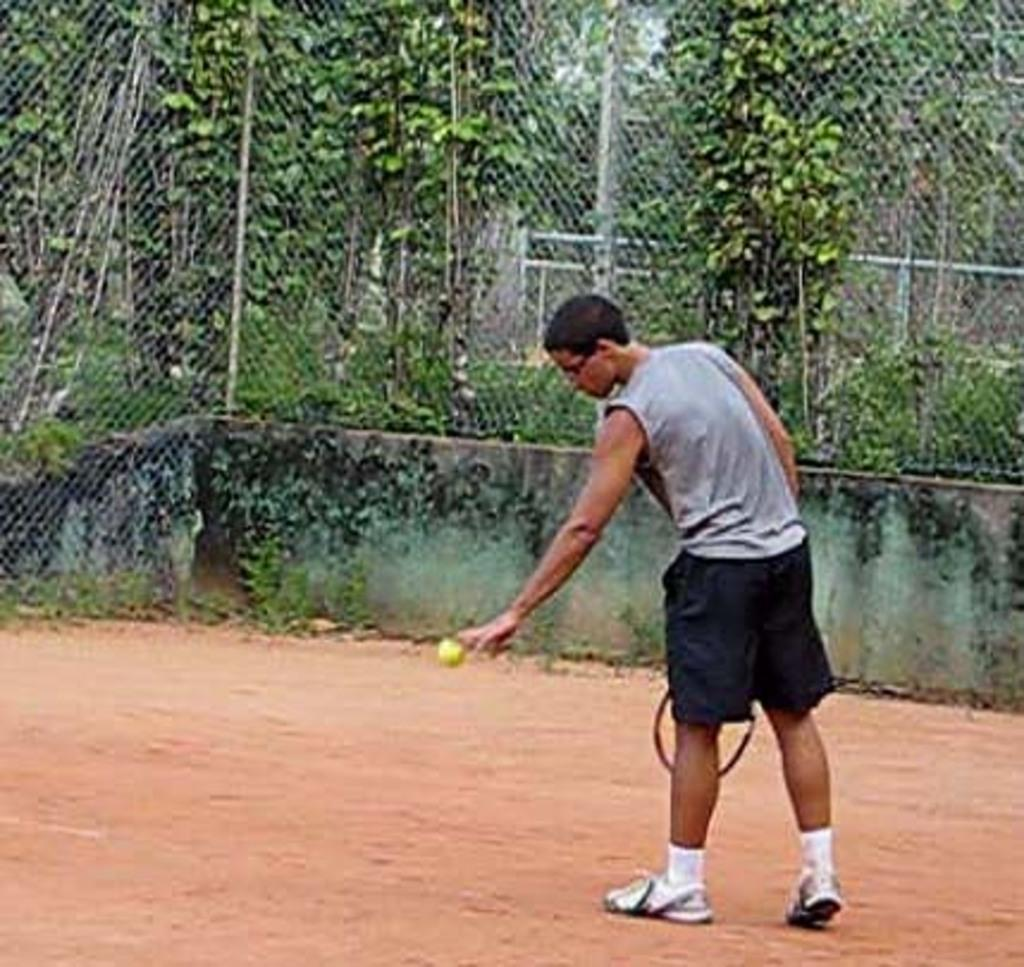What type of vegetation can be seen in the image? There are trees in the image. What structure is present in the image? There is a fence in the image. What activity is the man in the image engaged in? The man is holding a shuttle bat and boll in the image, which suggests he might be playing badminton. Can you see a rabbit playing with a jewel in the image? There is no rabbit or jewel present in the image. Is the man in the image sleeping while holding the shuttle bat and boll? The man is not sleeping in the image; he is holding the shuttle bat and boll, which suggests he is engaged in the activity of playing badminton. 